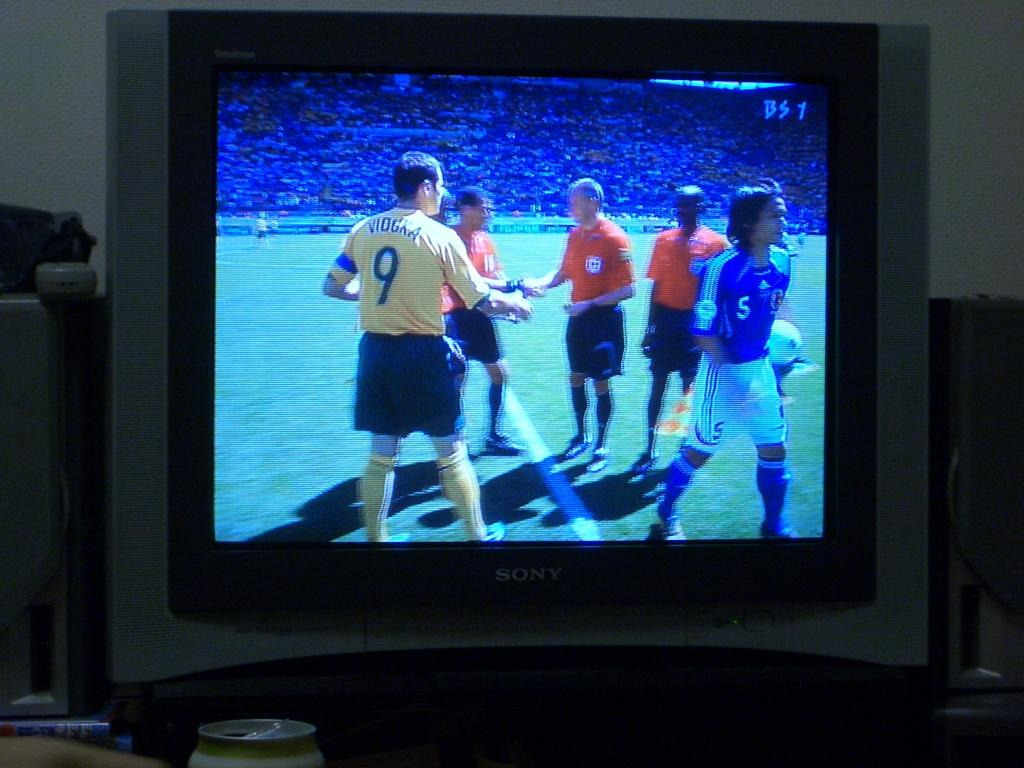<image>
Present a compact description of the photo's key features. A picture on a TV that has a BS1 in the upper right corner. 